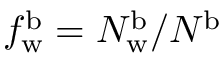Convert formula to latex. <formula><loc_0><loc_0><loc_500><loc_500>f _ { w } ^ { b } = N _ { w } ^ { b } / N ^ { b }</formula> 